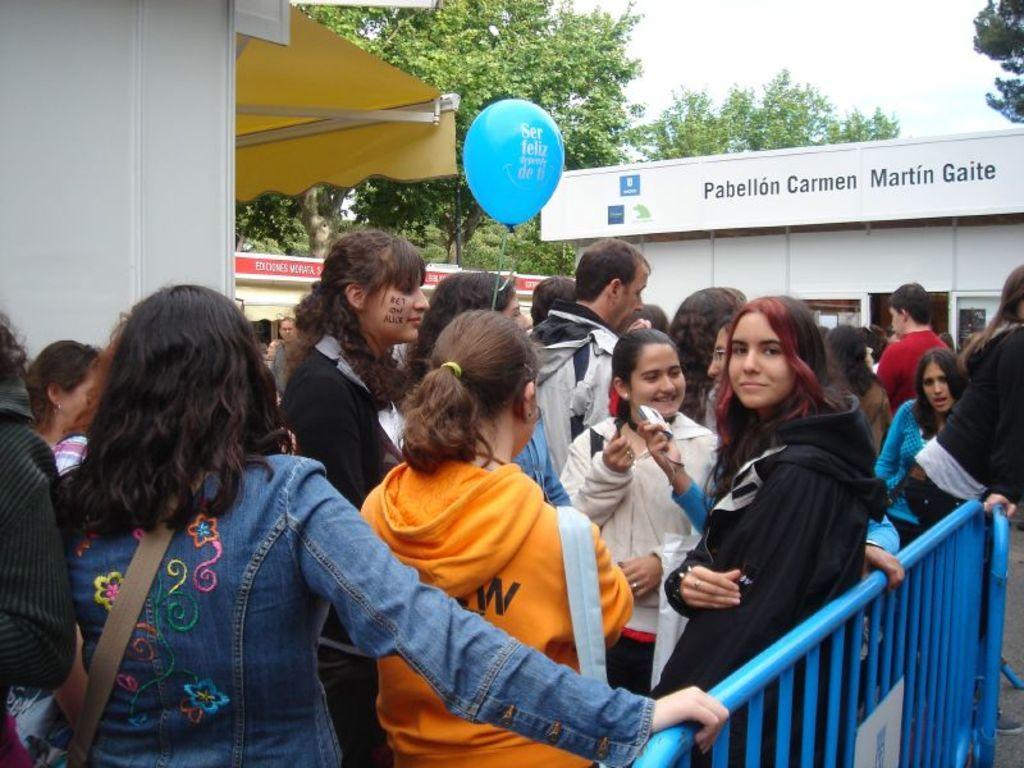In one or two sentences, can you explain what this image depicts? In the foreground of this image, there are people standing. Few are wearing bags and a person is holding a balloon. In the background, there are buildings, trees and the sky. 